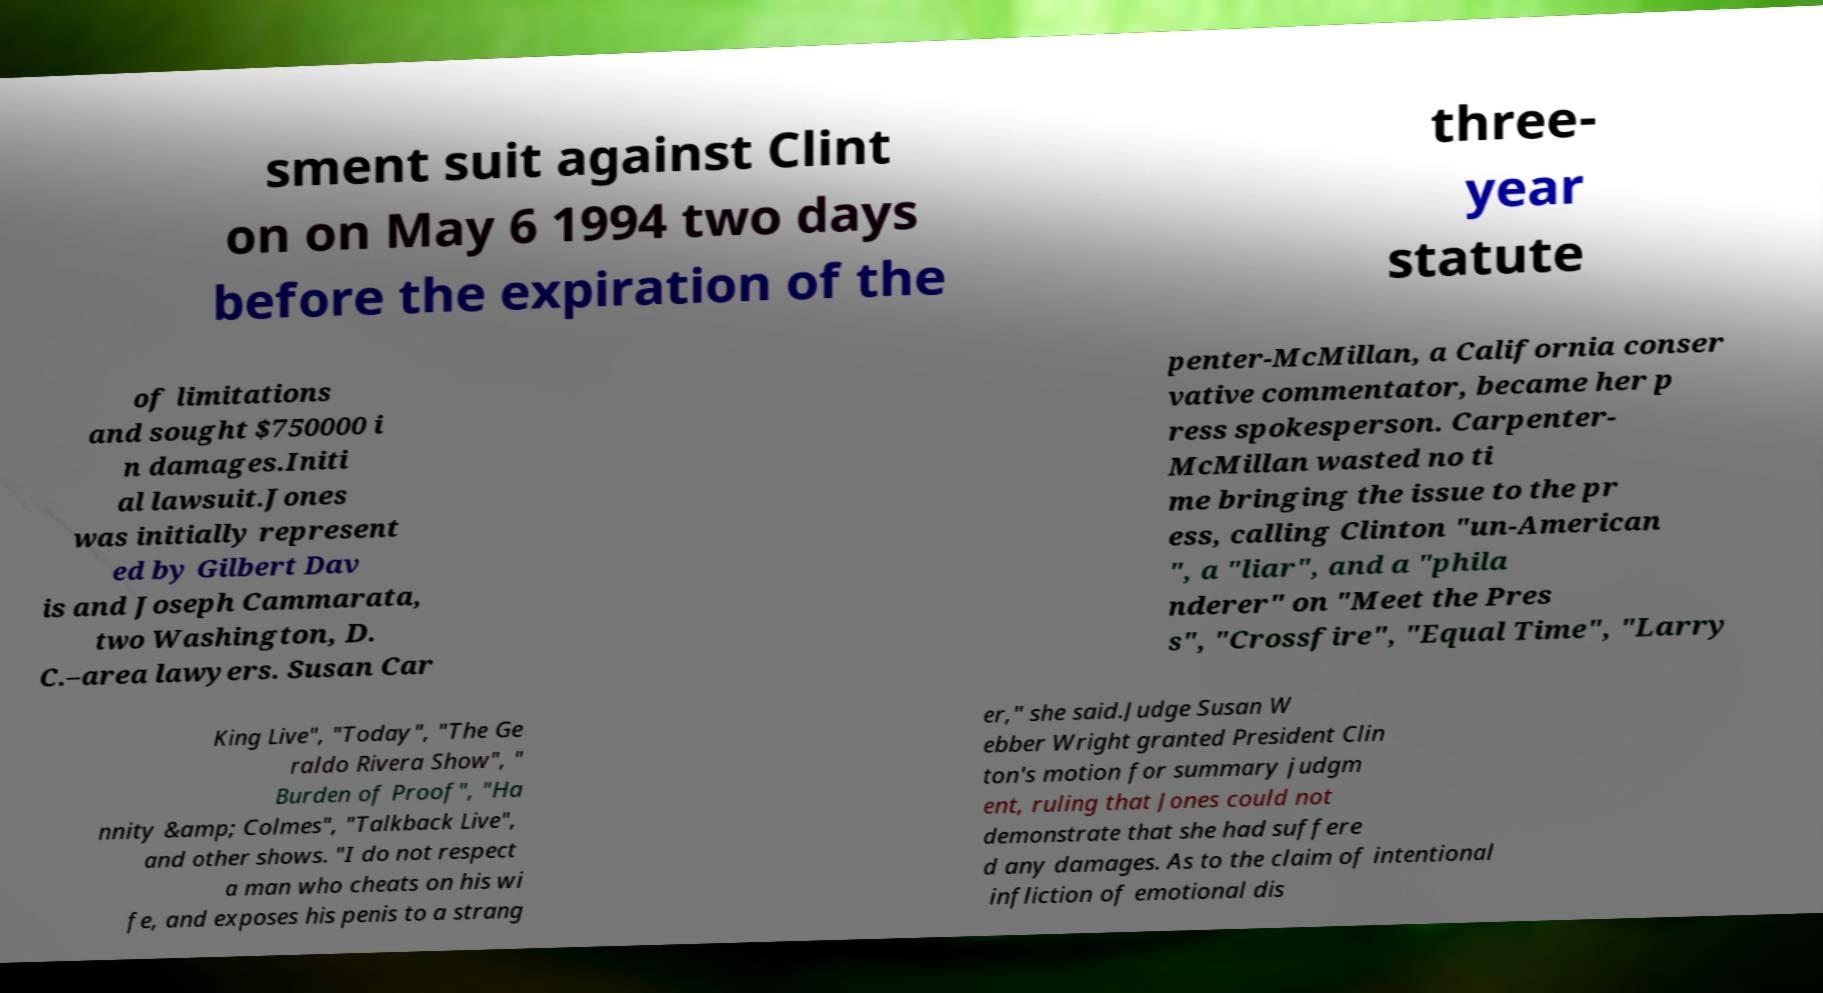Could you extract and type out the text from this image? sment suit against Clint on on May 6 1994 two days before the expiration of the three- year statute of limitations and sought $750000 i n damages.Initi al lawsuit.Jones was initially represent ed by Gilbert Dav is and Joseph Cammarata, two Washington, D. C.–area lawyers. Susan Car penter-McMillan, a California conser vative commentator, became her p ress spokesperson. Carpenter- McMillan wasted no ti me bringing the issue to the pr ess, calling Clinton "un-American ", a "liar", and a "phila nderer" on "Meet the Pres s", "Crossfire", "Equal Time", "Larry King Live", "Today", "The Ge raldo Rivera Show", " Burden of Proof", "Ha nnity &amp; Colmes", "Talkback Live", and other shows. "I do not respect a man who cheats on his wi fe, and exposes his penis to a strang er," she said.Judge Susan W ebber Wright granted President Clin ton's motion for summary judgm ent, ruling that Jones could not demonstrate that she had suffere d any damages. As to the claim of intentional infliction of emotional dis 